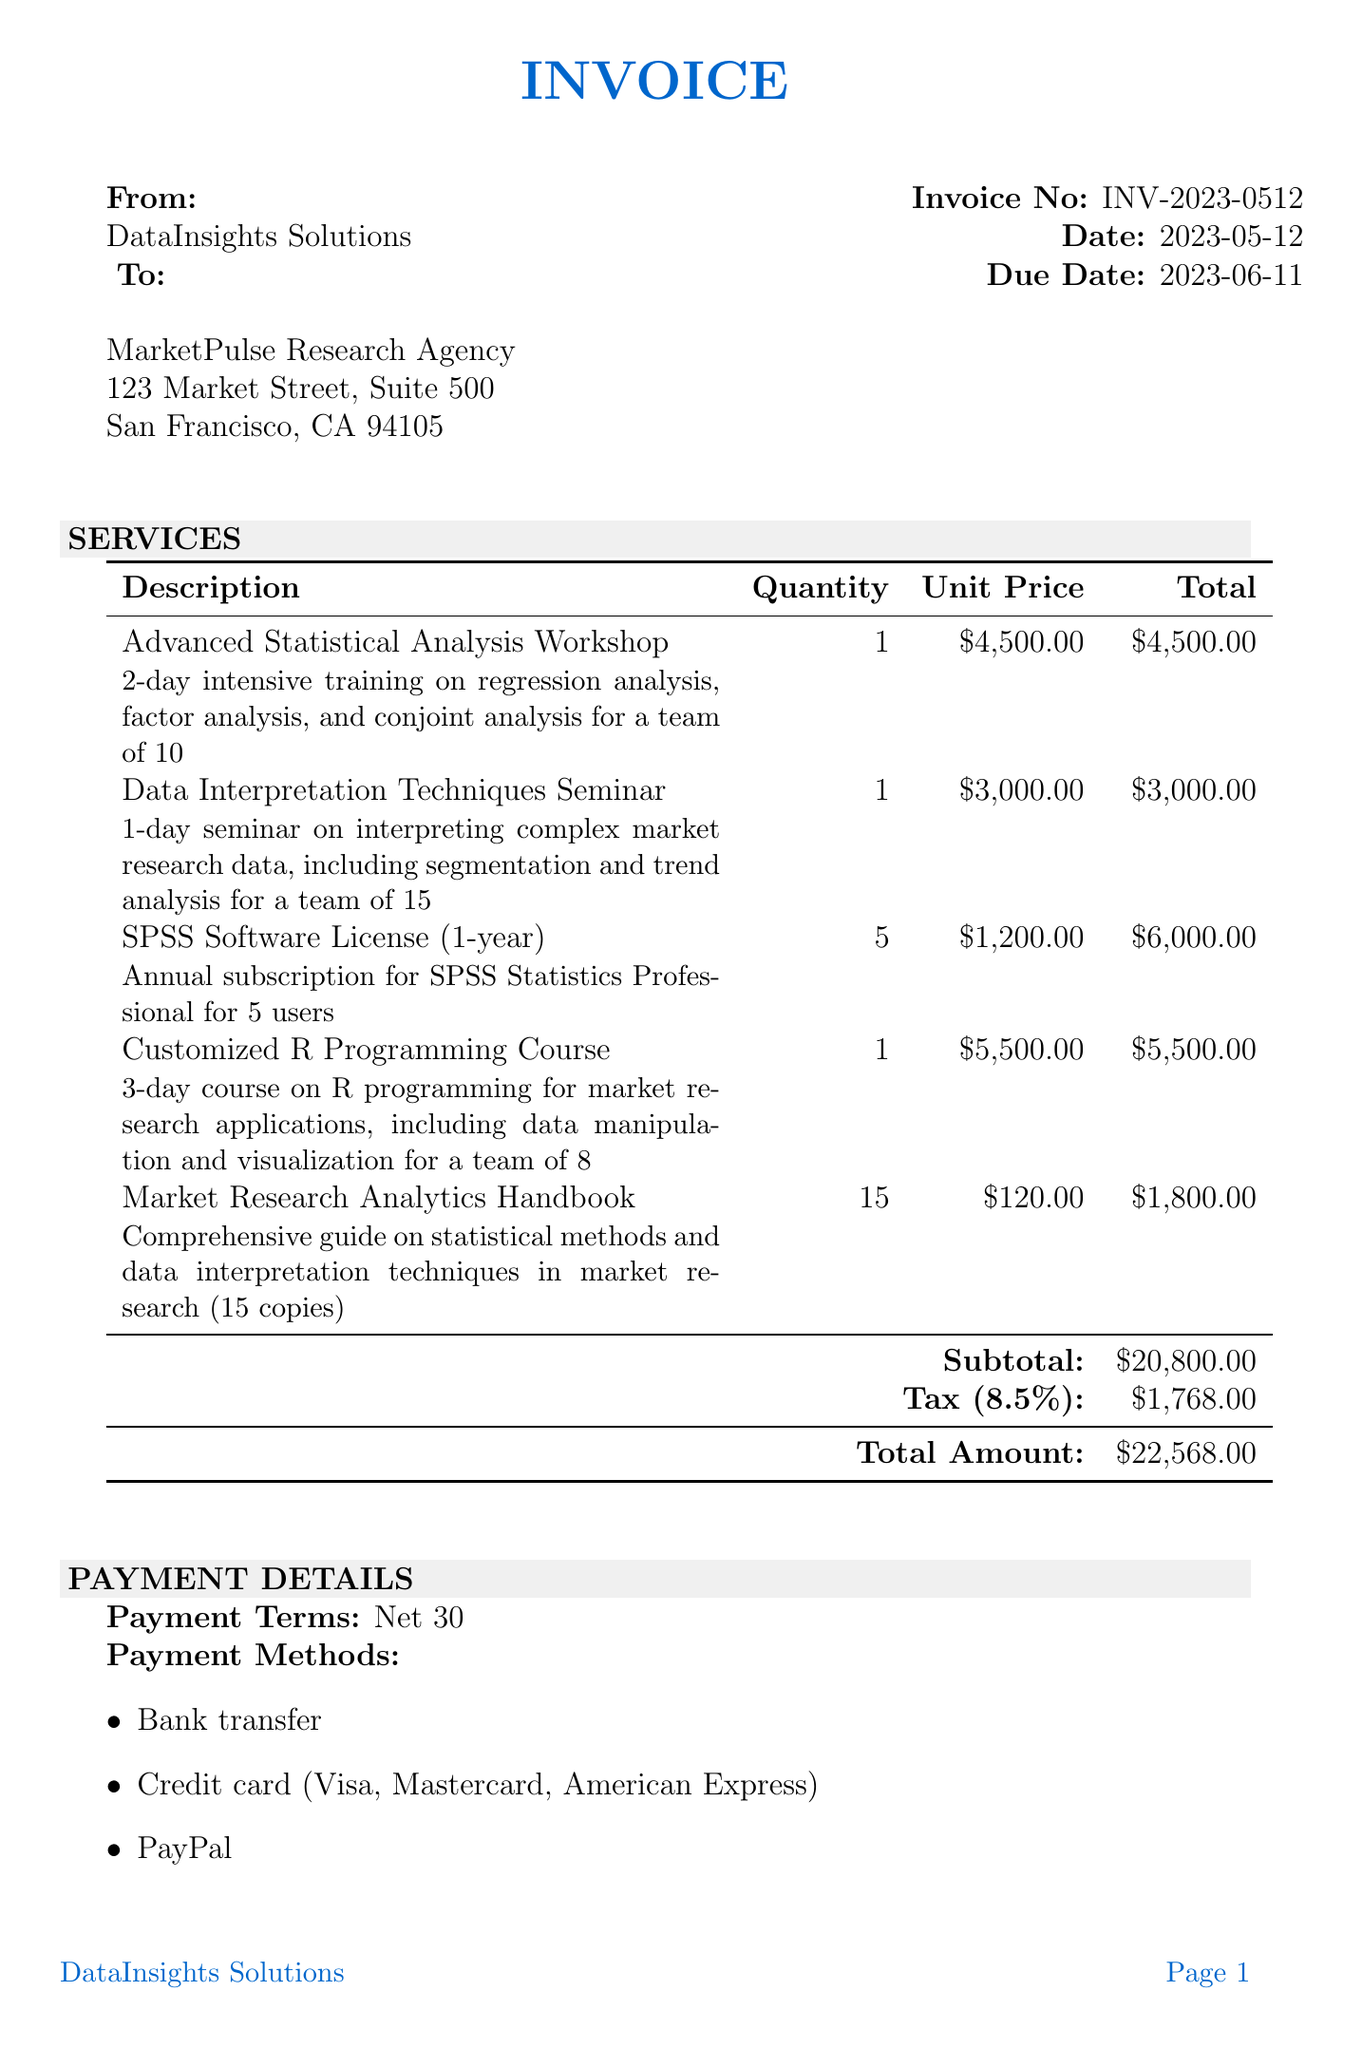What is the invoice number? The invoice number is specifically listed in the document for reference.
Answer: INV-2023-0512 What is the total amount due? The total amount due is prominently stated at the end of the invoice.
Answer: $22,568.00 When is the due date? The due date is clearly mentioned to indicate when payment is expected.
Answer: 2023-06-11 How many users does the SPSS Software License cover? This information is found in the details of the corresponding item.
Answer: 5 What is the subtotal of the services listed? The subtotal is provided before the tax calculation.
Answer: $20,800.00 What is the tax rate applied on the invoice? The tax rate is specified as part of the payment calculations.
Answer: 8.5% How many copies of the Market Research Analytics Handbook were ordered? This quantity is detailed in the item description for that handbook.
Answer: 15 What payment methods are accepted? The document lists the various payment methods available for settling the invoice.
Answer: Bank transfer, Credit card (Visa, Mastercard, American Express), PayPal What type of training is provided in the "Advanced Statistical Analysis Workshop"? The description provides insight into the content of the workshop provided.
Answer: 2-day intensive training on regression analysis, factor analysis, and conjoint analysis for a team of 10 